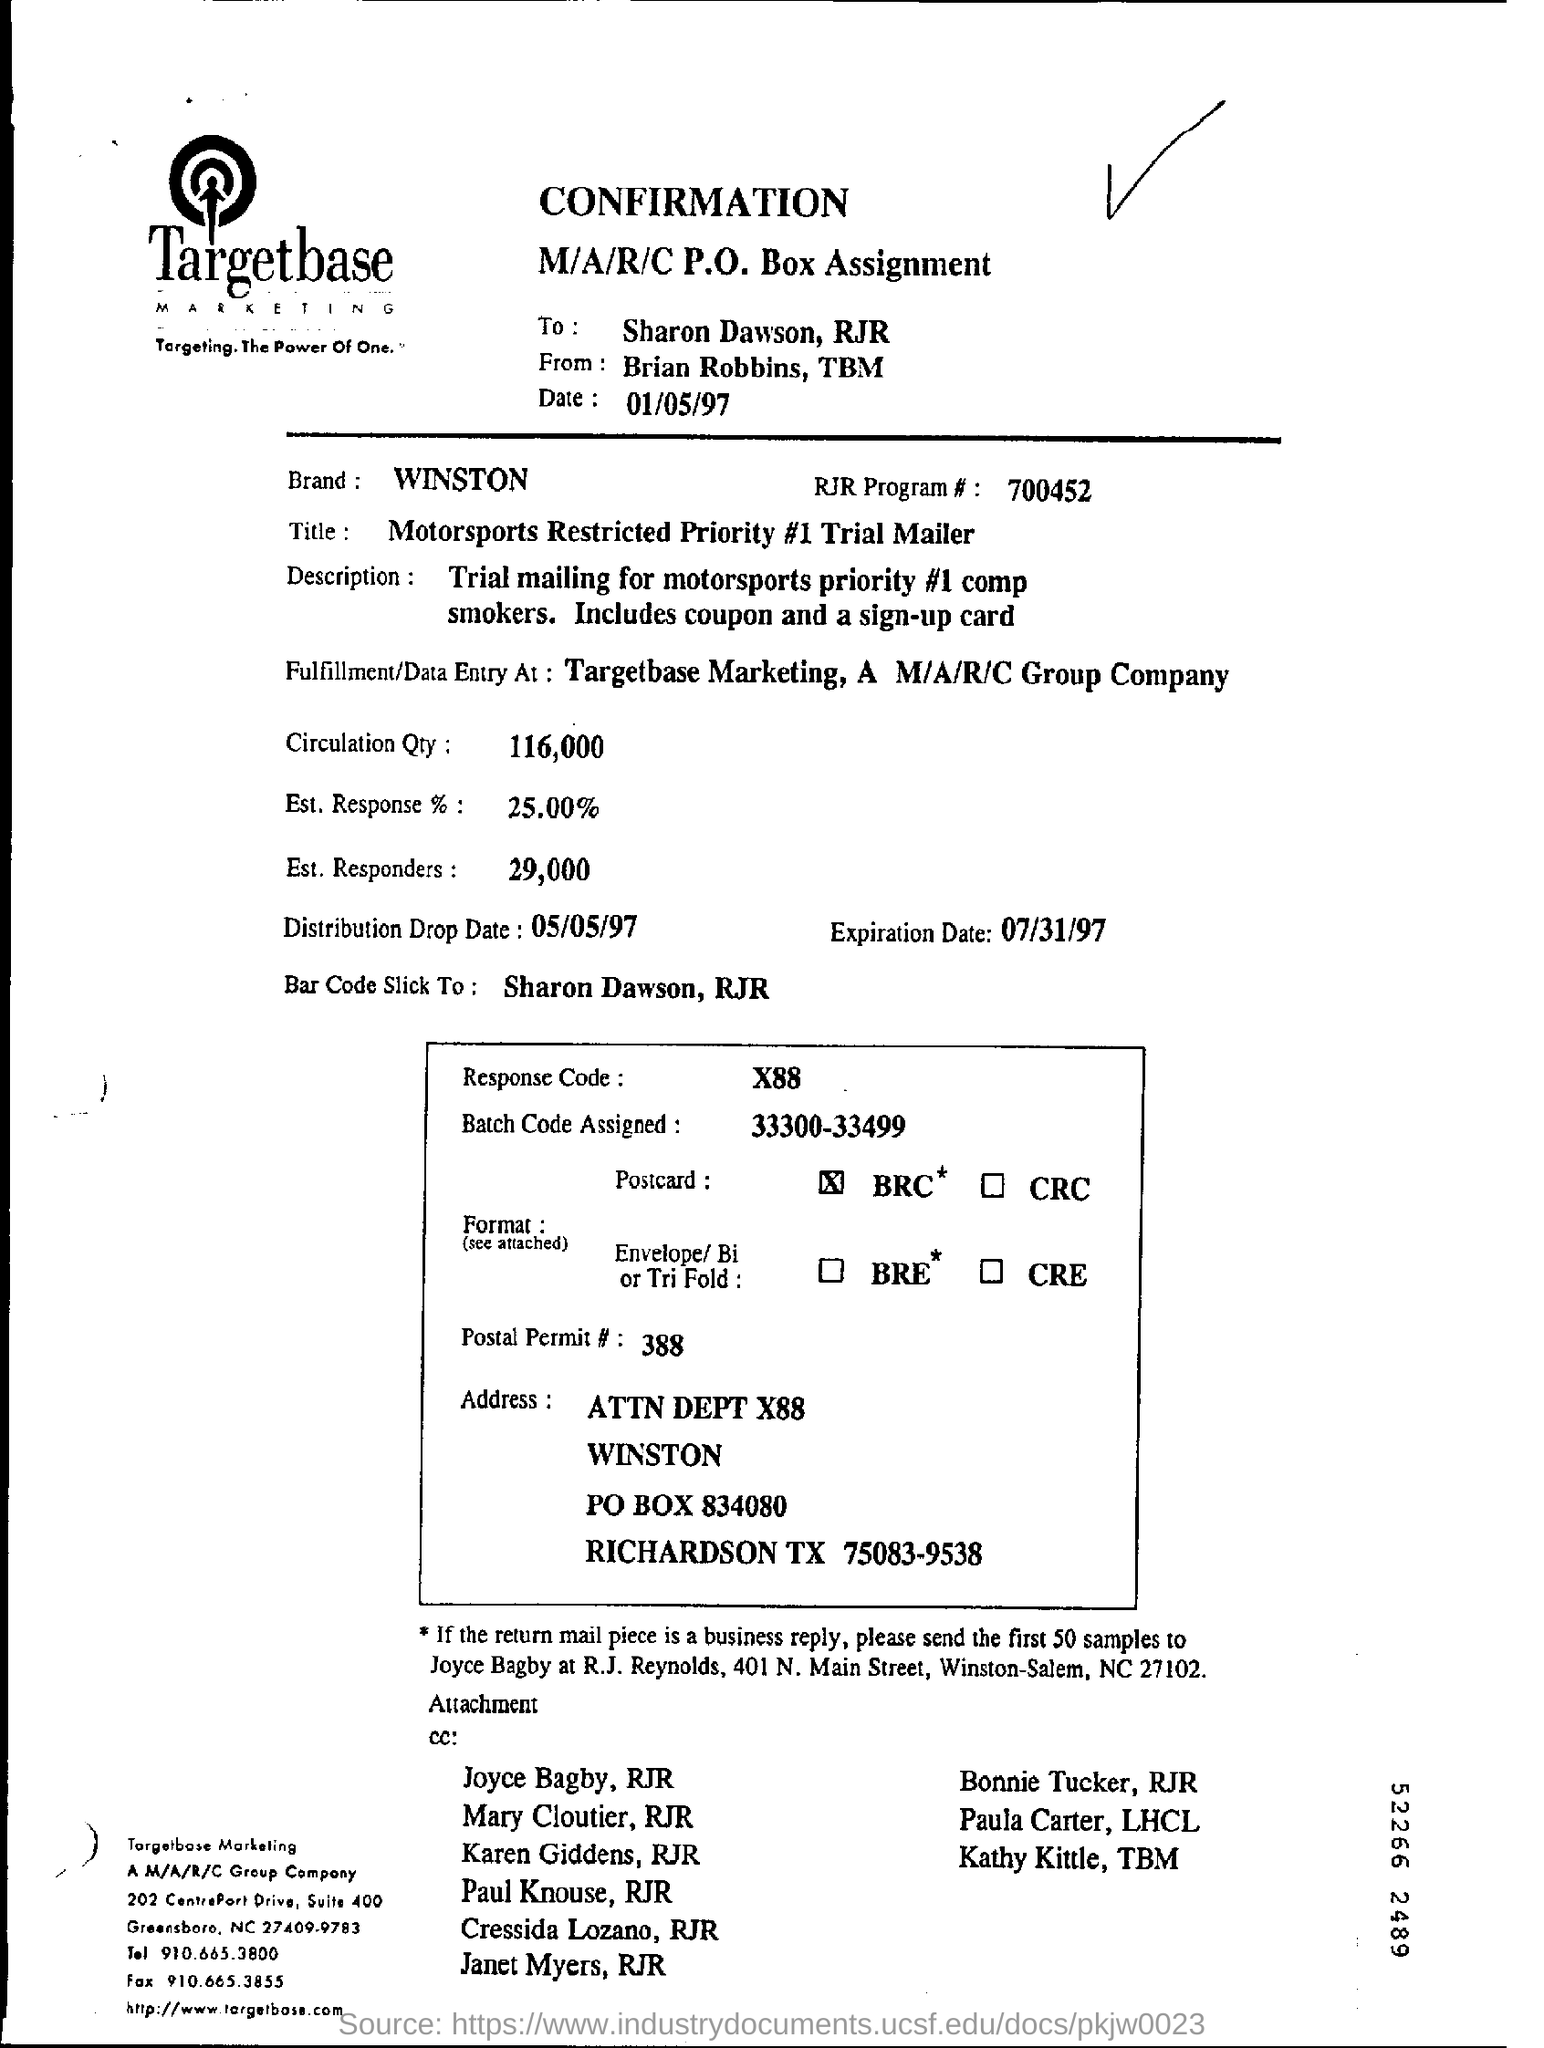Outline some significant characteristics in this image. The expiration date is July 31, 1997. The distribution drop date is May 5, 1997. On the top of the document, the date is mentioned as 01/05/97. The RJR Program# mentioned in the form is 700452. The brand name is WINSTON. 